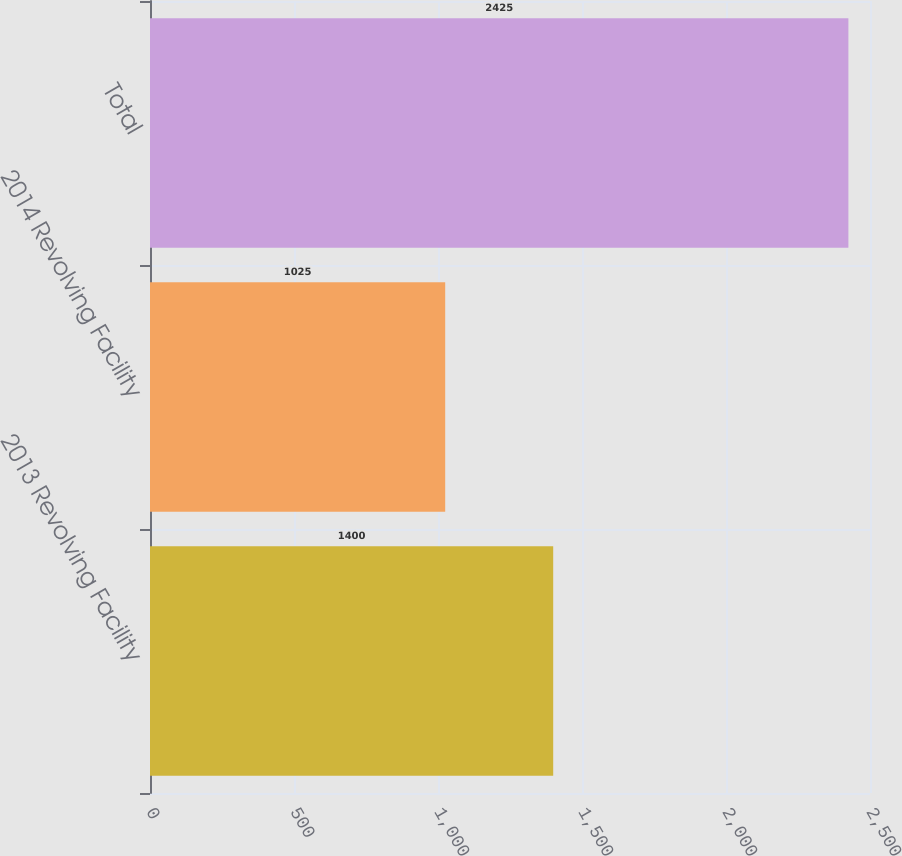Convert chart. <chart><loc_0><loc_0><loc_500><loc_500><bar_chart><fcel>2013 Revolving Facility<fcel>2014 Revolving Facility<fcel>Total<nl><fcel>1400<fcel>1025<fcel>2425<nl></chart> 